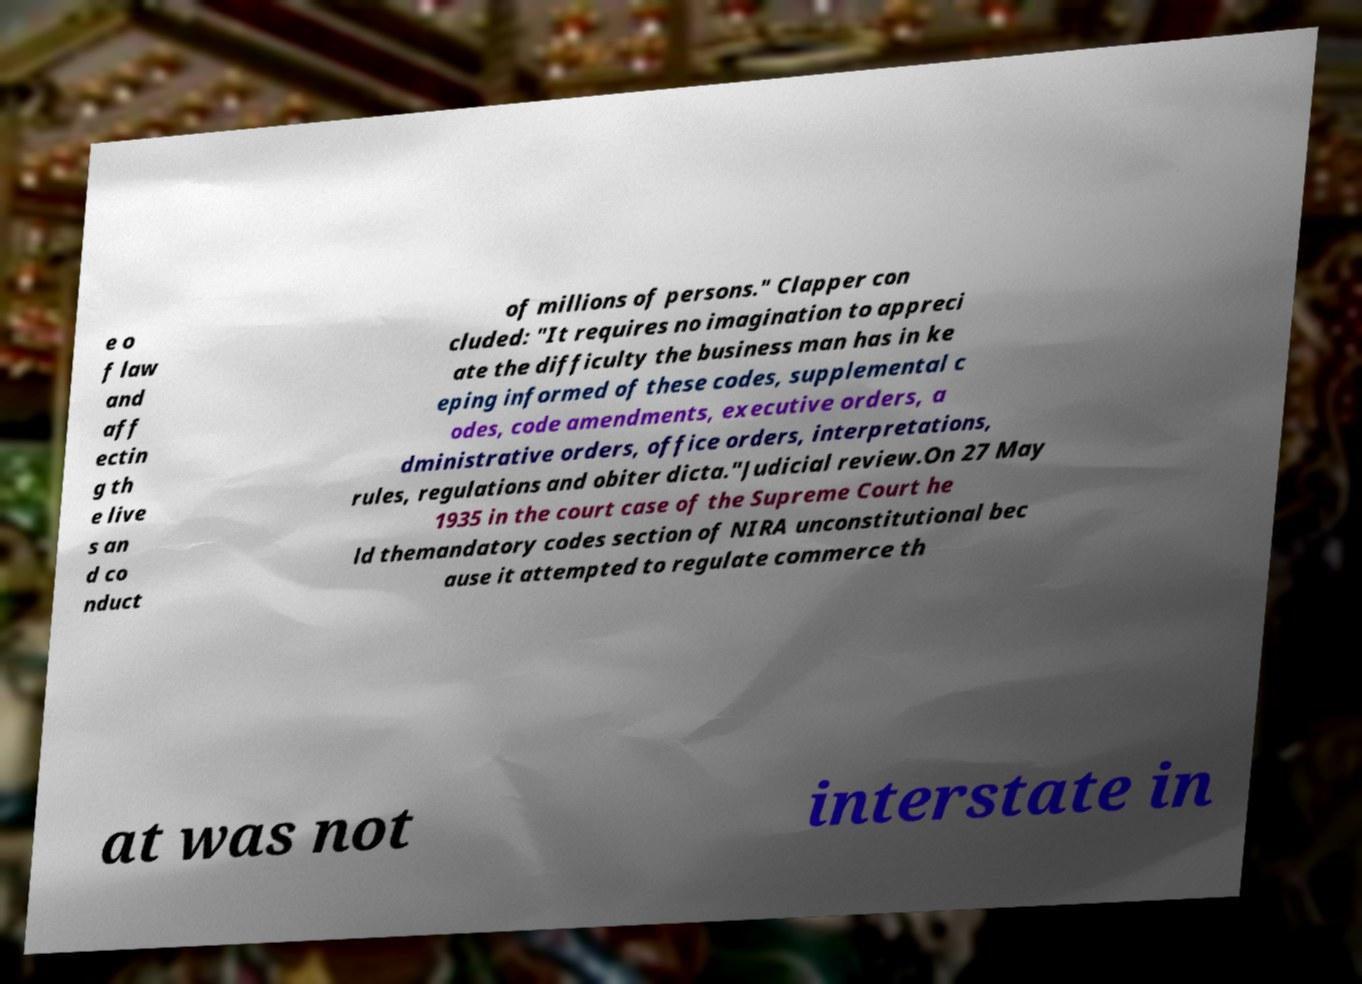For documentation purposes, I need the text within this image transcribed. Could you provide that? e o f law and aff ectin g th e live s an d co nduct of millions of persons." Clapper con cluded: "It requires no imagination to appreci ate the difficulty the business man has in ke eping informed of these codes, supplemental c odes, code amendments, executive orders, a dministrative orders, office orders, interpretations, rules, regulations and obiter dicta."Judicial review.On 27 May 1935 in the court case of the Supreme Court he ld themandatory codes section of NIRA unconstitutional bec ause it attempted to regulate commerce th at was not interstate in 